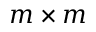Convert formula to latex. <formula><loc_0><loc_0><loc_500><loc_500>m \times m</formula> 